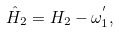<formula> <loc_0><loc_0><loc_500><loc_500>\hat { H } _ { 2 } = H _ { 2 } - \omega _ { 1 } ^ { ^ { \prime } } ,</formula> 